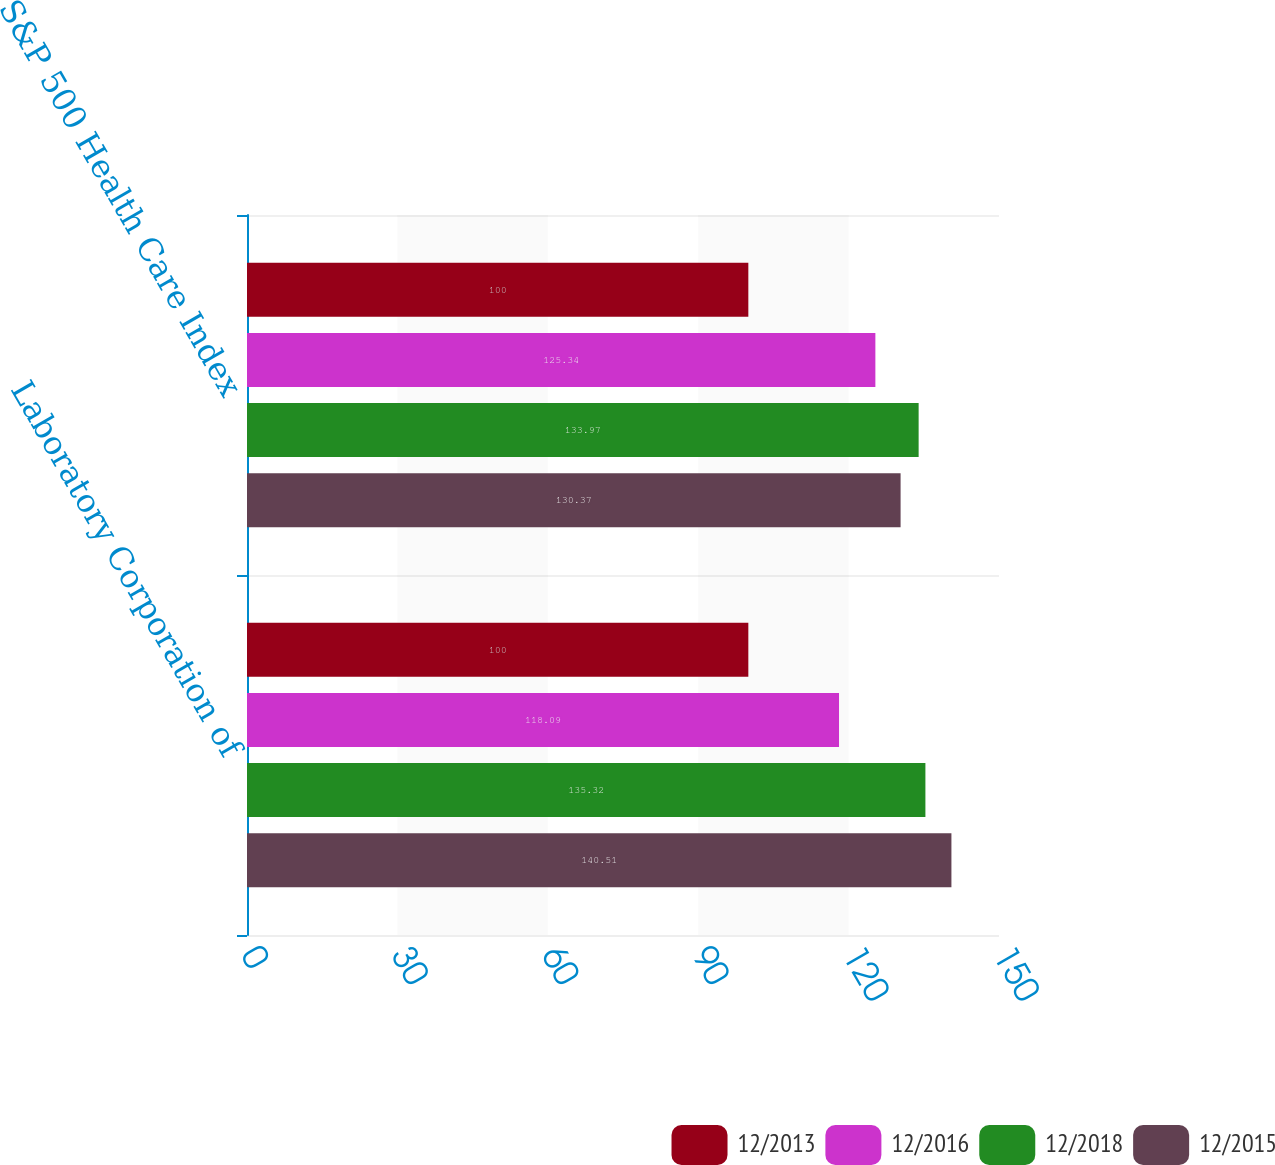Convert chart. <chart><loc_0><loc_0><loc_500><loc_500><stacked_bar_chart><ecel><fcel>Laboratory Corporation of<fcel>S&P 500 Health Care Index<nl><fcel>12/2013<fcel>100<fcel>100<nl><fcel>12/2016<fcel>118.09<fcel>125.34<nl><fcel>12/2018<fcel>135.32<fcel>133.97<nl><fcel>12/2015<fcel>140.51<fcel>130.37<nl></chart> 